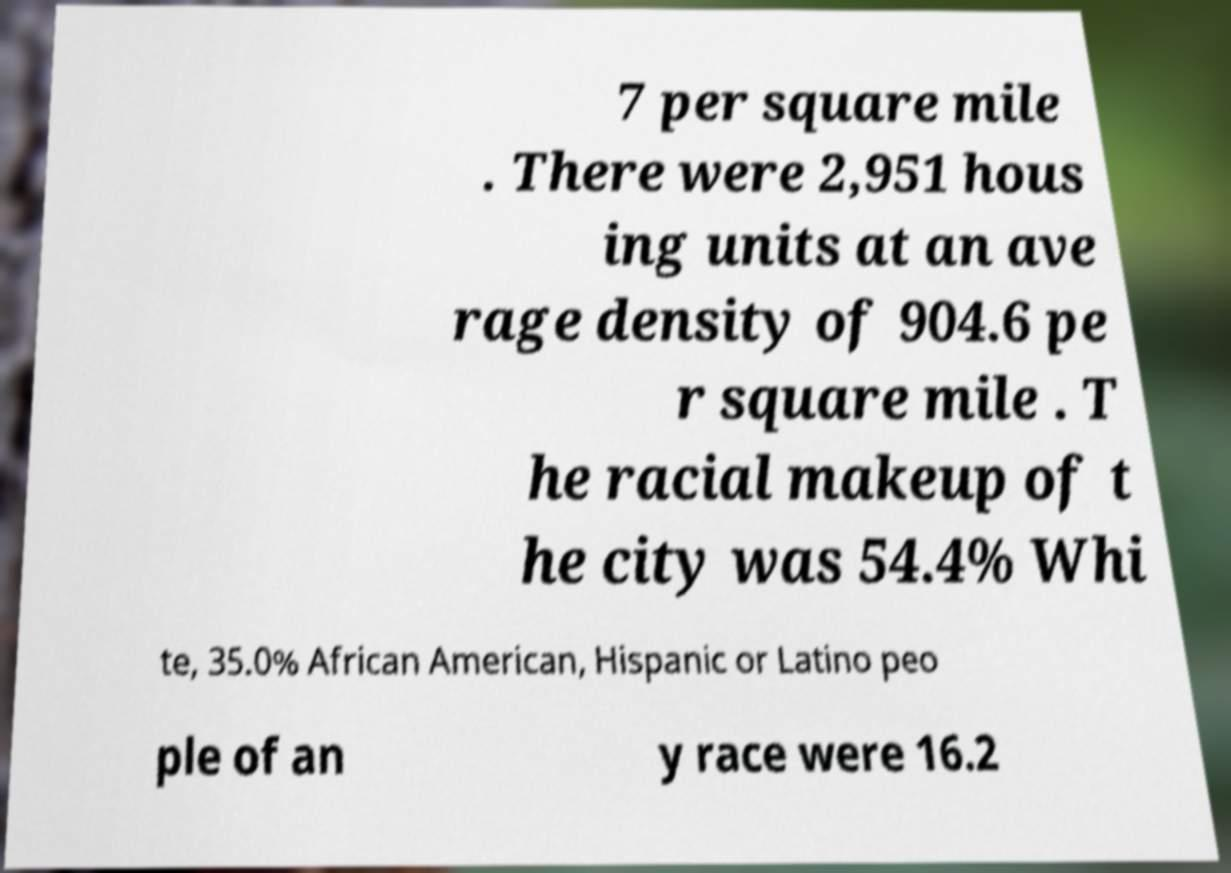I need the written content from this picture converted into text. Can you do that? 7 per square mile . There were 2,951 hous ing units at an ave rage density of 904.6 pe r square mile . T he racial makeup of t he city was 54.4% Whi te, 35.0% African American, Hispanic or Latino peo ple of an y race were 16.2 